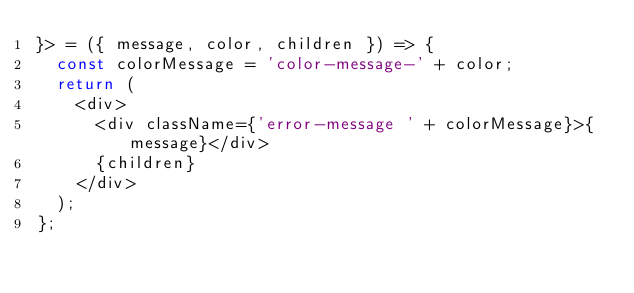Convert code to text. <code><loc_0><loc_0><loc_500><loc_500><_TypeScript_>}> = ({ message, color, children }) => {
  const colorMessage = 'color-message-' + color;
  return (
    <div>
      <div className={'error-message ' + colorMessage}>{message}</div>
      {children}
    </div>
  );
};

</code> 